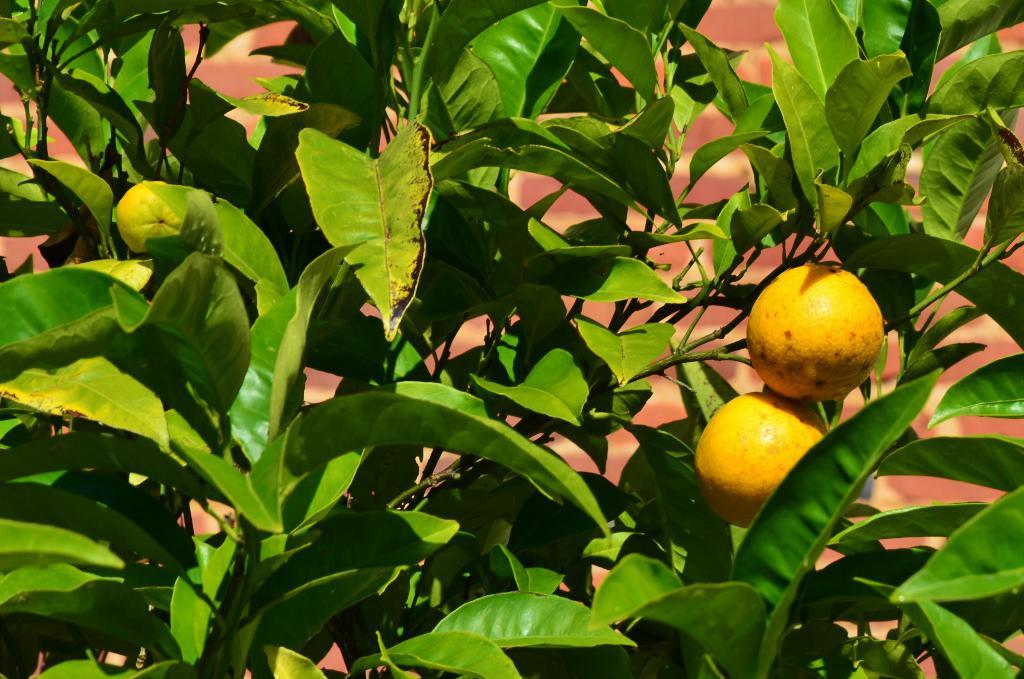What is present in the image that represents a living organism? There is a tree in the image. How many fruits can be seen in the image? There are two fruits in the image. What color is the background behind the tree? The background of the tree is red in color. What type of rhythm can be heard coming from the tree in the image? There is no sound or rhythm present in the image, as it features a tree and fruits. Is the image a print or a digital representation? The nature of the image (print or digital) is not mentioned in the provided facts, so it cannot be determined from the information given. 